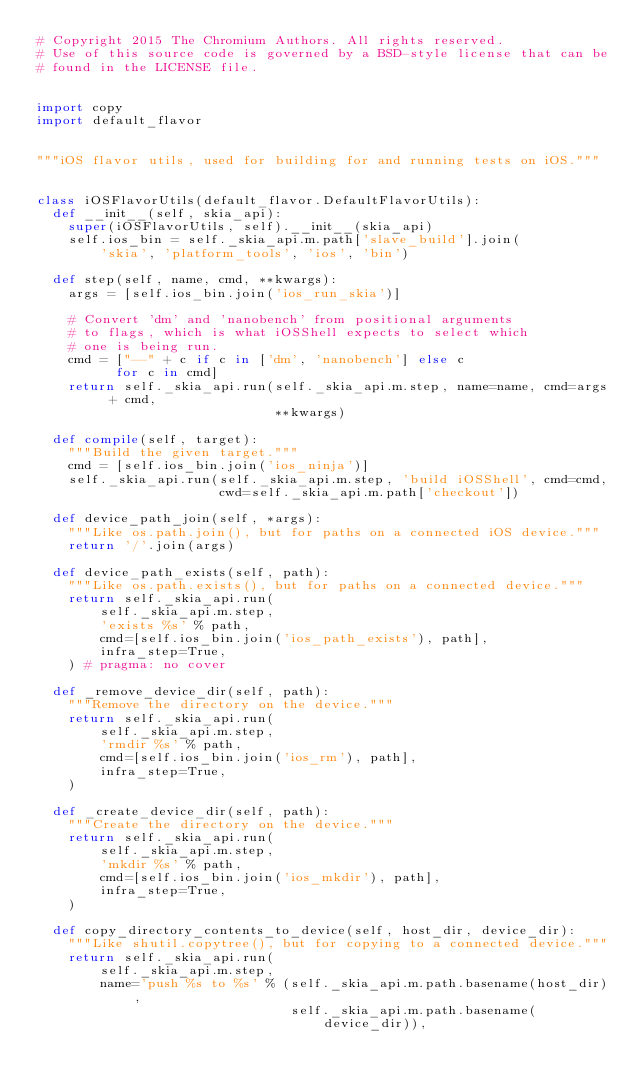<code> <loc_0><loc_0><loc_500><loc_500><_Python_># Copyright 2015 The Chromium Authors. All rights reserved.
# Use of this source code is governed by a BSD-style license that can be
# found in the LICENSE file.


import copy
import default_flavor


"""iOS flavor utils, used for building for and running tests on iOS."""


class iOSFlavorUtils(default_flavor.DefaultFlavorUtils):
  def __init__(self, skia_api):
    super(iOSFlavorUtils, self).__init__(skia_api)
    self.ios_bin = self._skia_api.m.path['slave_build'].join(
        'skia', 'platform_tools', 'ios', 'bin')

  def step(self, name, cmd, **kwargs):
    args = [self.ios_bin.join('ios_run_skia')]

    # Convert 'dm' and 'nanobench' from positional arguments
    # to flags, which is what iOSShell expects to select which
    # one is being run.
    cmd = ["--" + c if c in ['dm', 'nanobench'] else c
          for c in cmd]
    return self._skia_api.run(self._skia_api.m.step, name=name, cmd=args + cmd,
                              **kwargs)

  def compile(self, target):
    """Build the given target."""
    cmd = [self.ios_bin.join('ios_ninja')]
    self._skia_api.run(self._skia_api.m.step, 'build iOSShell', cmd=cmd,
                       cwd=self._skia_api.m.path['checkout'])

  def device_path_join(self, *args):
    """Like os.path.join(), but for paths on a connected iOS device."""
    return '/'.join(args)

  def device_path_exists(self, path):
    """Like os.path.exists(), but for paths on a connected device."""
    return self._skia_api.run(
        self._skia_api.m.step,
        'exists %s' % path,
        cmd=[self.ios_bin.join('ios_path_exists'), path],
        infra_step=True,
    ) # pragma: no cover

  def _remove_device_dir(self, path):
    """Remove the directory on the device."""
    return self._skia_api.run(
        self._skia_api.m.step,
        'rmdir %s' % path,
        cmd=[self.ios_bin.join('ios_rm'), path],
        infra_step=True,
    )

  def _create_device_dir(self, path):
    """Create the directory on the device."""
    return self._skia_api.run(
        self._skia_api.m.step,
        'mkdir %s' % path,
        cmd=[self.ios_bin.join('ios_mkdir'), path],
        infra_step=True,
    )

  def copy_directory_contents_to_device(self, host_dir, device_dir):
    """Like shutil.copytree(), but for copying to a connected device."""
    return self._skia_api.run(
        self._skia_api.m.step,
        name='push %s to %s' % (self._skia_api.m.path.basename(host_dir),
                                self._skia_api.m.path.basename(device_dir)),</code> 